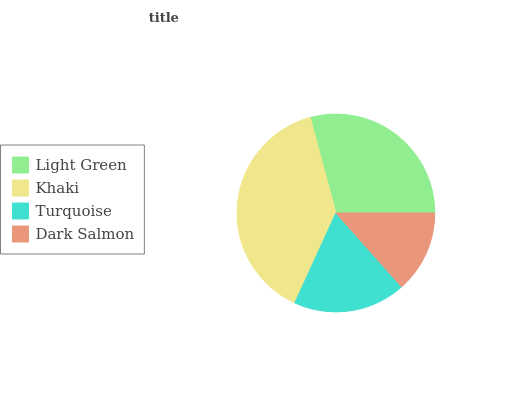Is Dark Salmon the minimum?
Answer yes or no. Yes. Is Khaki the maximum?
Answer yes or no. Yes. Is Turquoise the minimum?
Answer yes or no. No. Is Turquoise the maximum?
Answer yes or no. No. Is Khaki greater than Turquoise?
Answer yes or no. Yes. Is Turquoise less than Khaki?
Answer yes or no. Yes. Is Turquoise greater than Khaki?
Answer yes or no. No. Is Khaki less than Turquoise?
Answer yes or no. No. Is Light Green the high median?
Answer yes or no. Yes. Is Turquoise the low median?
Answer yes or no. Yes. Is Dark Salmon the high median?
Answer yes or no. No. Is Dark Salmon the low median?
Answer yes or no. No. 